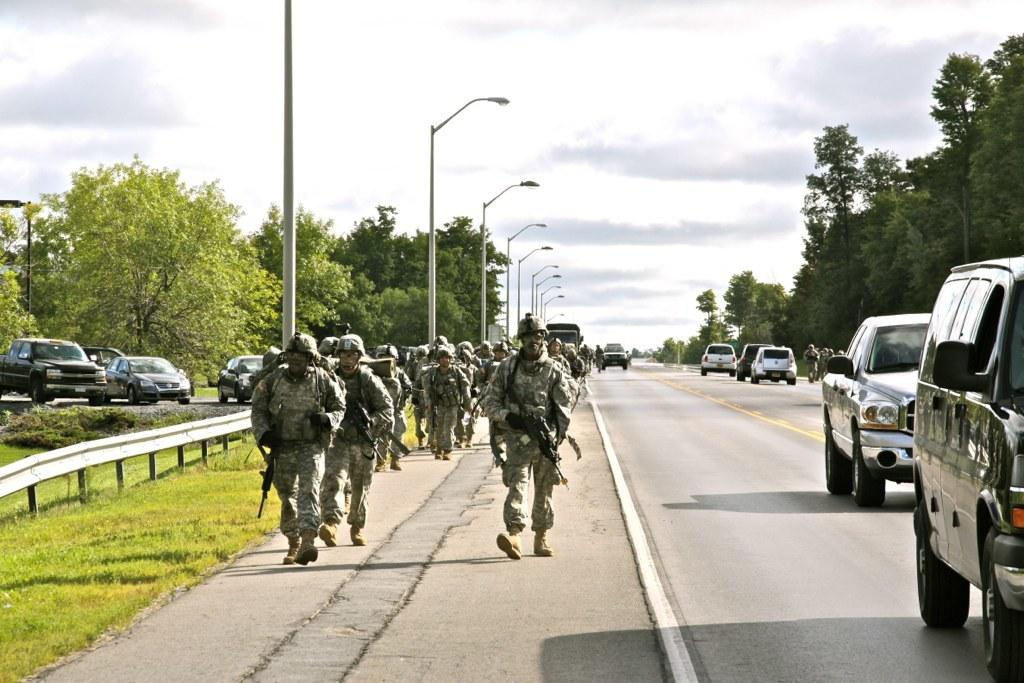What are the men in the image doing? The men in the image are marching on the road. What else can be seen on the road besides the marching men? Motor vehicles are present on the road. What structures are visible along the road? Street poles and street lights are present in the image. What type of vegetation is visible in the image? Trees and grass are visible in the image. What is the condition of the sky in the image? The sky is visible in the image, and clouds are present. What type of flight is taking off in the image? There is no flight present in the image; it features men marching on the road, motor vehicles, street poles, street lights, trees, grass, and the sky with clouds. How many trains are visible in the image? There are no trains present in the image. 